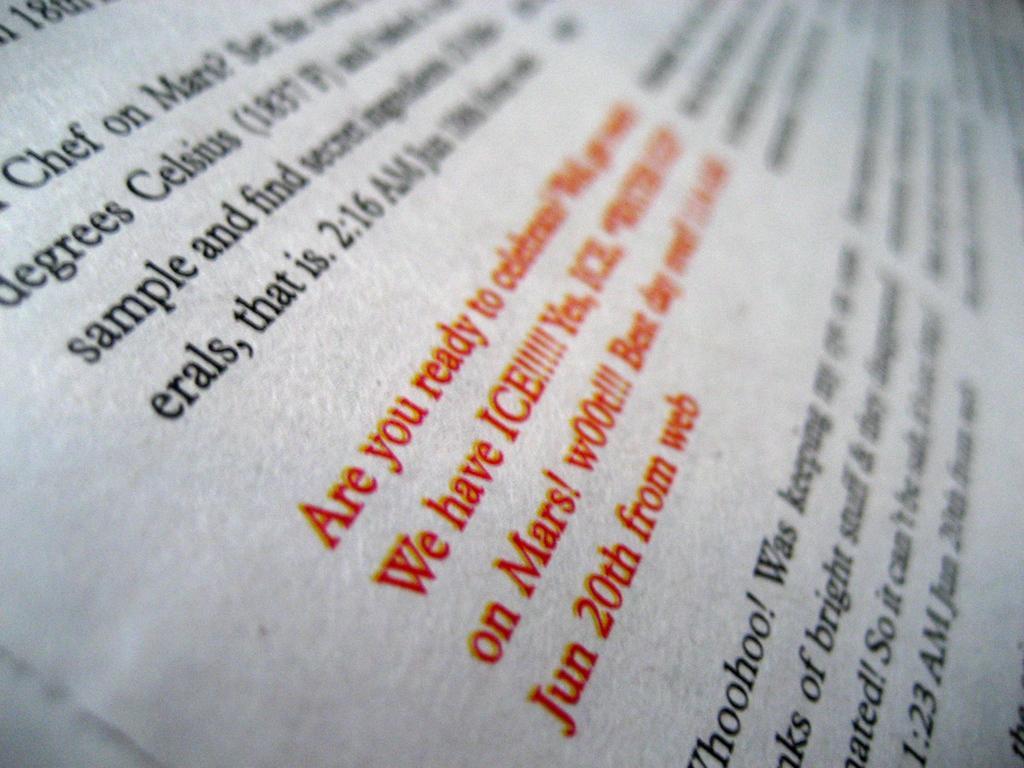Please provide a concise description of this image. In this picture I can see text in red color and black color. 